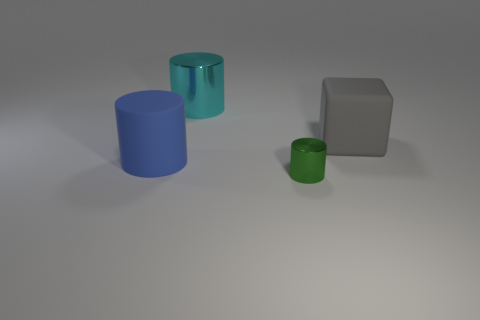Is there anything else that has the same size as the green cylinder?
Provide a short and direct response. No. What material is the large cyan object that is the same shape as the tiny green thing?
Provide a succinct answer. Metal. There is a cyan thing that is made of the same material as the small green cylinder; what shape is it?
Offer a very short reply. Cylinder. How many other things have the same shape as the green metal object?
Ensure brevity in your answer.  2. What shape is the large object right of the metal object that is behind the green shiny object?
Your answer should be compact. Cube. Is the size of the matte thing that is left of the cyan cylinder the same as the big cyan thing?
Ensure brevity in your answer.  Yes. There is a object that is both on the left side of the small metal thing and in front of the large gray block; how big is it?
Offer a very short reply. Large. How many other matte cylinders are the same size as the blue rubber cylinder?
Offer a very short reply. 0. How many objects are behind the metallic object behind the small thing?
Offer a terse response. 0. There is a metallic object right of the large cylinder that is behind the large blue thing; are there any gray blocks that are left of it?
Your response must be concise. No. 